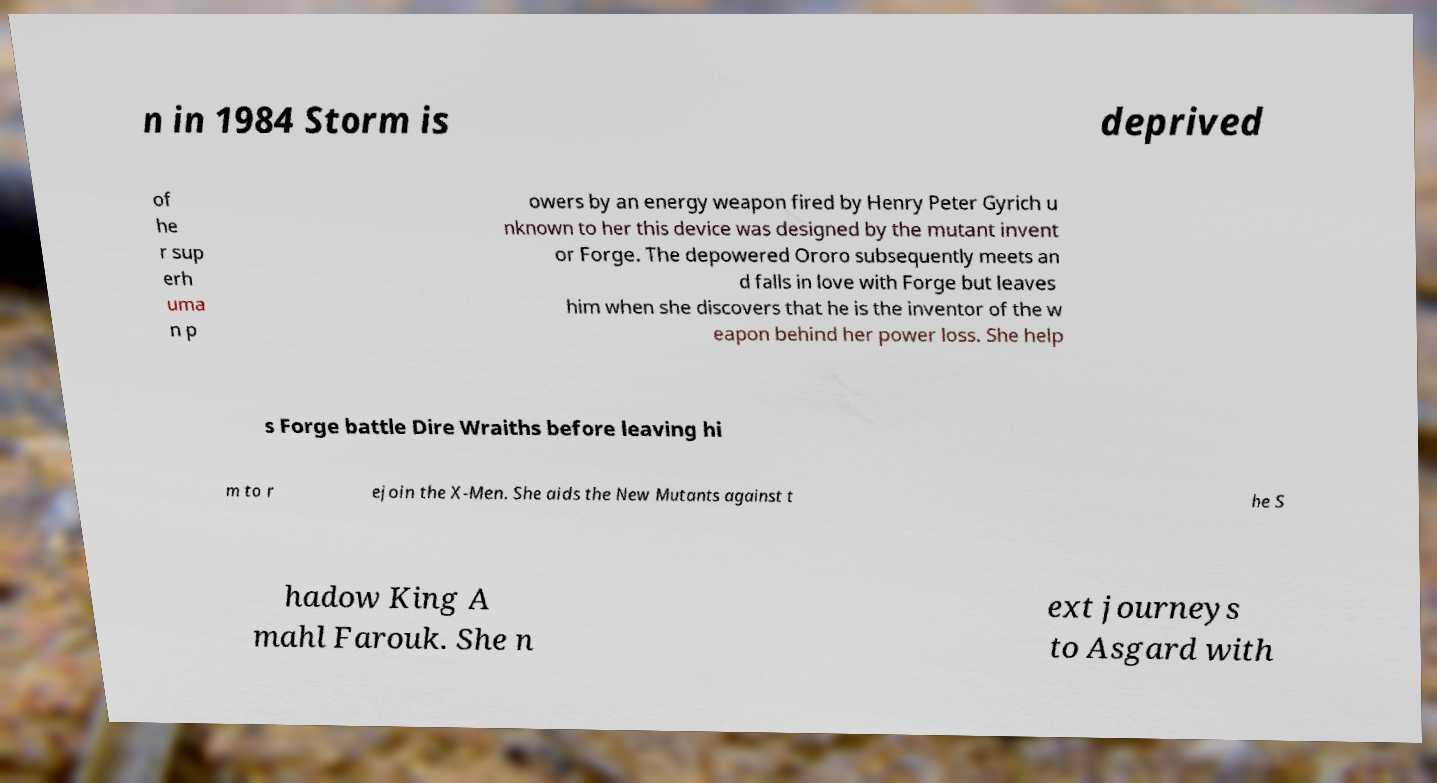For documentation purposes, I need the text within this image transcribed. Could you provide that? n in 1984 Storm is deprived of he r sup erh uma n p owers by an energy weapon fired by Henry Peter Gyrich u nknown to her this device was designed by the mutant invent or Forge. The depowered Ororo subsequently meets an d falls in love with Forge but leaves him when she discovers that he is the inventor of the w eapon behind her power loss. She help s Forge battle Dire Wraiths before leaving hi m to r ejoin the X-Men. She aids the New Mutants against t he S hadow King A mahl Farouk. She n ext journeys to Asgard with 